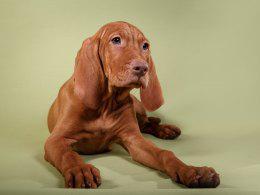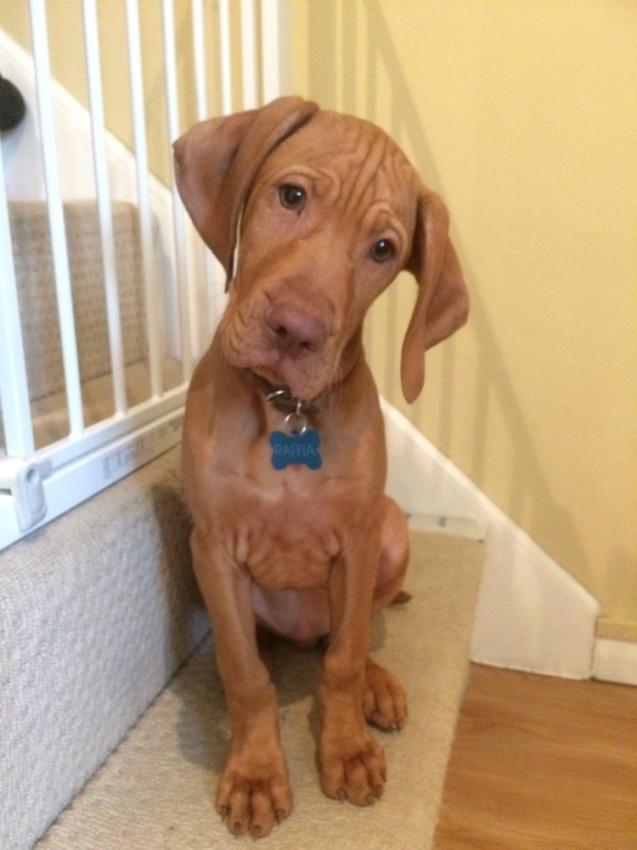The first image is the image on the left, the second image is the image on the right. Given the left and right images, does the statement "In at least one image you can see a single brown dog looking straight forward who is wearing a coller." hold true? Answer yes or no. Yes. The first image is the image on the left, the second image is the image on the right. Analyze the images presented: Is the assertion "At least two dogs are wearing black collars and at least half of the dogs are looking upward." valid? Answer yes or no. No. 